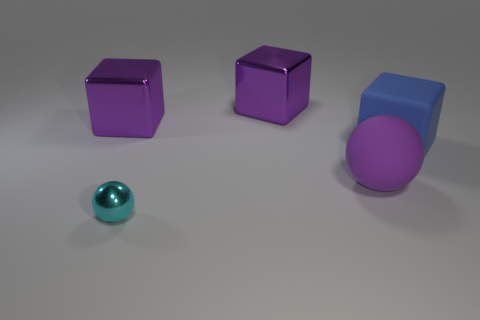Add 4 large gray matte things. How many objects exist? 9 Subtract all cubes. How many objects are left? 2 Add 5 shiny cubes. How many shiny cubes exist? 7 Subtract 0 blue balls. How many objects are left? 5 Subtract all green cubes. Subtract all large metallic things. How many objects are left? 3 Add 5 shiny objects. How many shiny objects are left? 8 